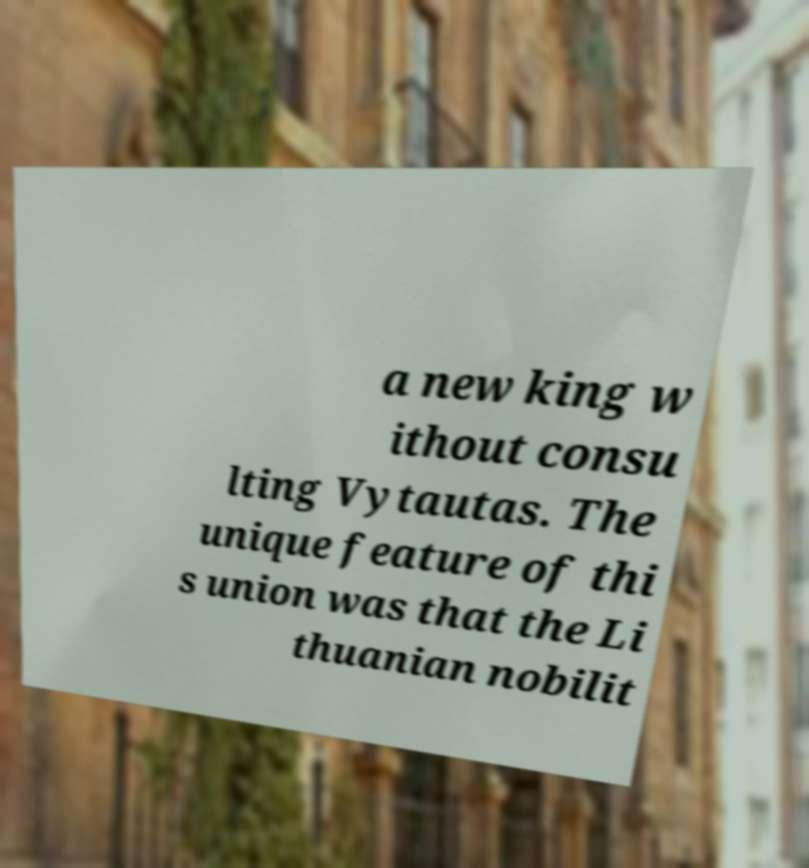Can you accurately transcribe the text from the provided image for me? a new king w ithout consu lting Vytautas. The unique feature of thi s union was that the Li thuanian nobilit 